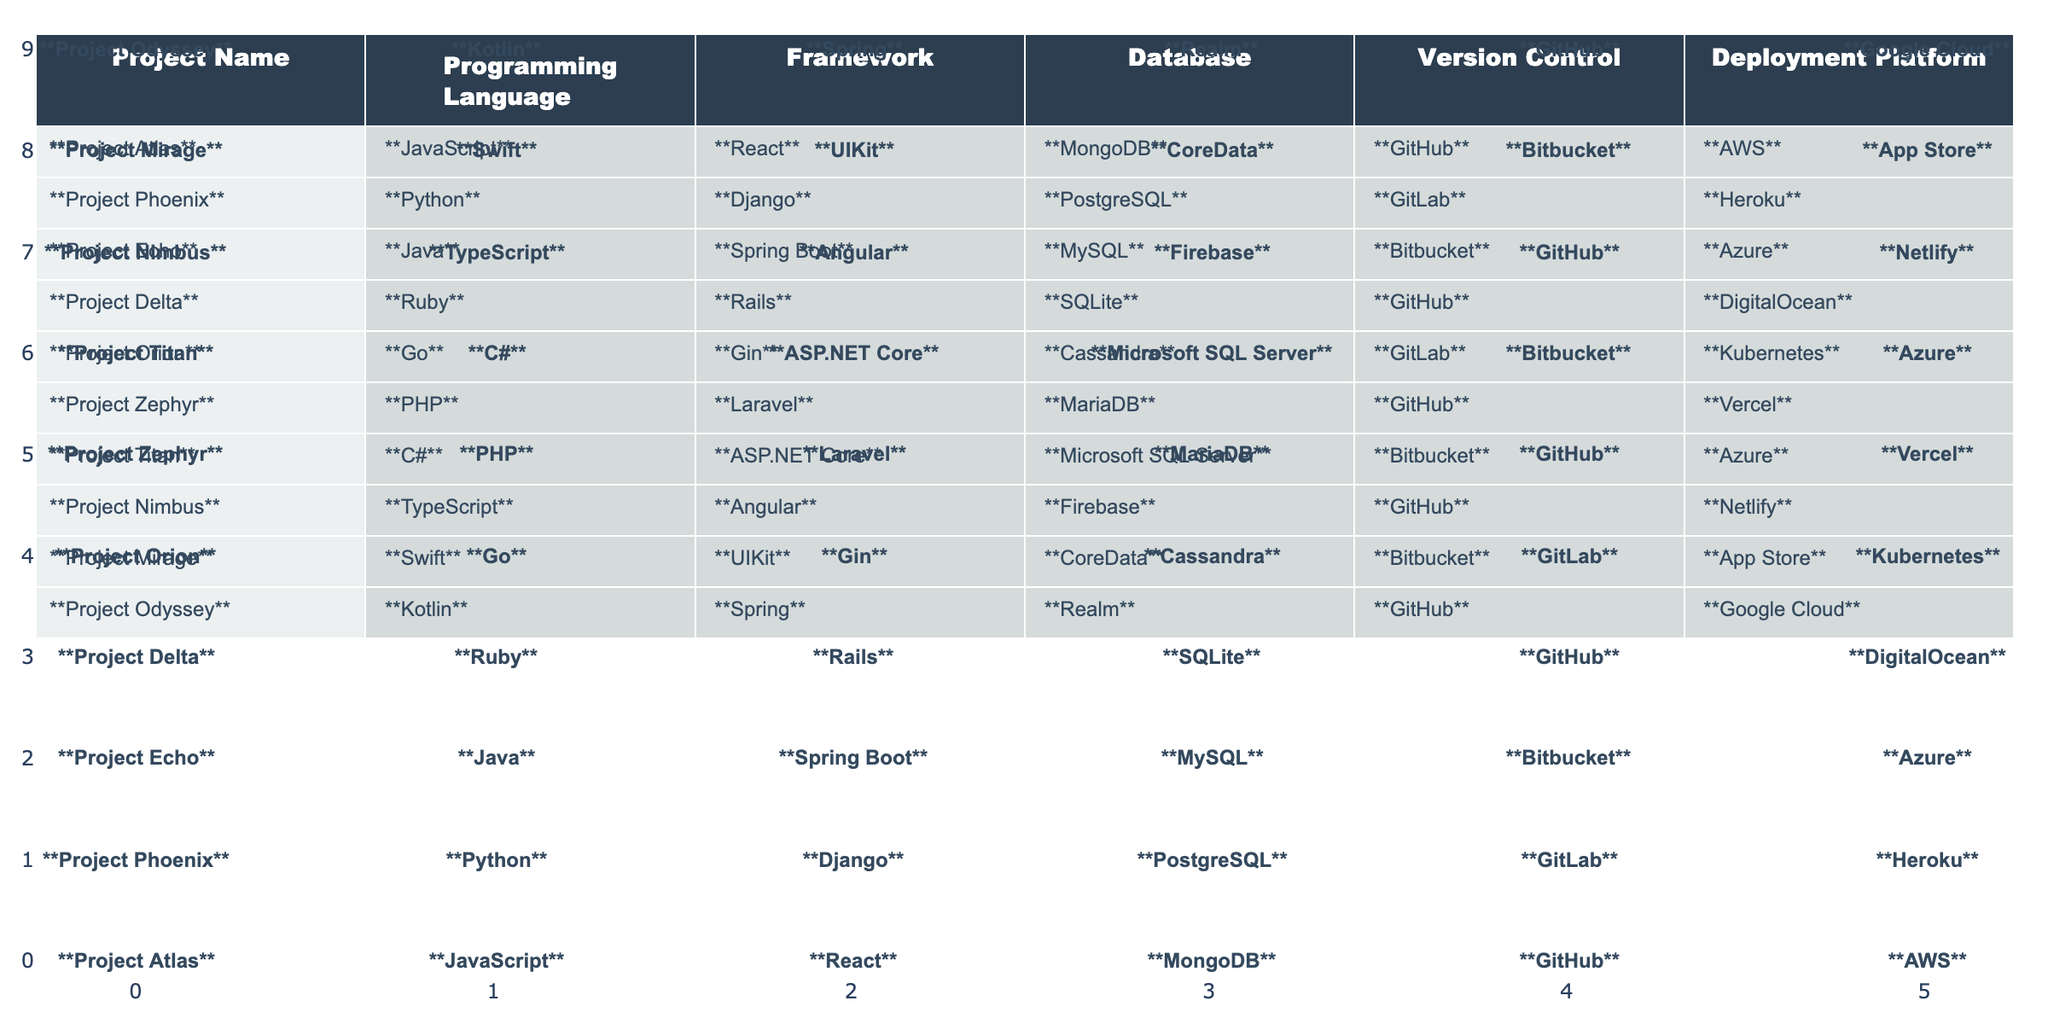What programming language is used in Project Atlas? Referring to the table, Project Atlas uses JavaScript as its programming language.
Answer: JavaScript Which project uses PostgreSQL as its database? Looking at the table, Project Phoenix is the project that utilizes PostgreSQL as its database.
Answer: Project Phoenix How many projects are deployed on AWS? By reviewing the table, only Project Atlas is listed as deployed on AWS, meaning there is 1 project with this deployment platform.
Answer: 1 Is there a project that uses both GitHub and a JavaScript framework? The table indicates that Project Atlas uses GitHub for version control and React, which is a JavaScript framework. Thus, yes, there is such a project.
Answer: Yes Which database is used the most among the projects? From the table, we consider the databases listed and see that MongoDB, PostgreSQL, MySQL, SQLite, Cassandra, MariaDB, Microsoft SQL Server, and Firebase are used. Since none appear more than once, there is no most-used database.
Answer: No If a project uses GitLab, what programming language(s) does it utilize? The table shows two entries for GitLab: Project Phoenix uses Python, and Project Orion uses Go. Therefore, the programming languages corresponding to GitLab are Python and Go.
Answer: Python, Go Which deployment platform is used by the most projects? Checking the deployment platforms, we see that AWS, Heroku, Azure, DigitalOcean, Kubernetes, Vercel, and Google Cloud each only appear once, but GitHub appears six times. Hence, GitHub is the most used deployment platform.
Answer: GitHub How many projects are developed in a combination of Python and a framework? According to the data, only one project named Project Phoenix is developed in Python with the Django framework, hence the total is 1 project.
Answer: 1 Which project uses the Ruby programming language and what is its deployment platform? The table lists Project Delta as using Ruby as its language, and its deployment platform is DigitalOcean. Therefore, Project Delta is the answer.
Answer: Project Delta, DigitalOcean Are there any projects that combine TypeScript with Angular? The table confirms that Project Nimbus uses TypeScript as its programming language along with Angular as its framework. Thus, there is such a project.
Answer: Yes Which project with a Java framework has a deployment platform other than AWS? The data shows that Project Echo uses a Java framework, specifically Spring Boot, and is deployed on Azure, making it the answer.
Answer: Project Echo What is the total number of unique frameworks used in these projects? By reviewing the frameworks listed in the table (React, Django, Spring Boot, Rails, Gin, Laravel, ASP.NET Core, Angular, UIKit, Spring), we count ten unique frameworks, supporting this as the answer.
Answer: 10 